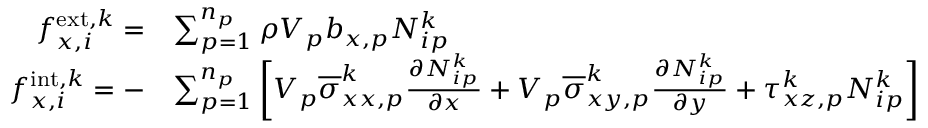Convert formula to latex. <formula><loc_0><loc_0><loc_500><loc_500>\begin{array} { r l } { f _ { x , i } ^ { e x t , k } = } & { \sum _ { p = 1 } ^ { n _ { p } } \rho V _ { p } b _ { x , p } N _ { i p } ^ { k } } \\ { f _ { x , i } ^ { i n t , k } = - } & { \sum _ { p = 1 } ^ { n _ { p } } \left [ V _ { p } \overline { \sigma } _ { x x , p } ^ { k } \frac { \partial N _ { i p } ^ { k } } { \partial x } + V _ { p } \overline { \sigma } _ { x y , p } ^ { k } \frac { \partial N _ { i p } ^ { k } } { \partial y } + \tau _ { x z , p } ^ { k } N _ { i p } ^ { k } \right ] } \end{array}</formula> 